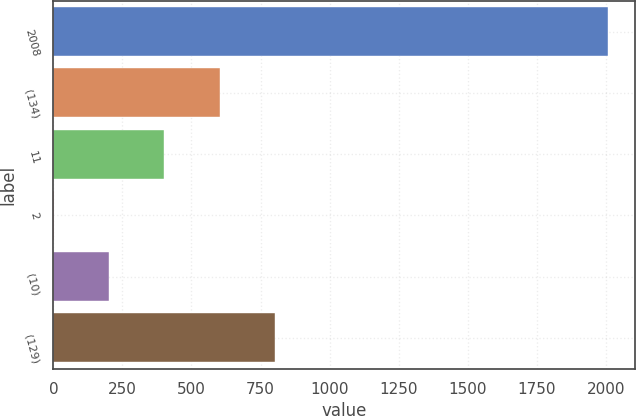Convert chart to OTSL. <chart><loc_0><loc_0><loc_500><loc_500><bar_chart><fcel>2008<fcel>(134)<fcel>11<fcel>2<fcel>(10)<fcel>(129)<nl><fcel>2007<fcel>602.59<fcel>401.96<fcel>0.7<fcel>201.33<fcel>803.22<nl></chart> 